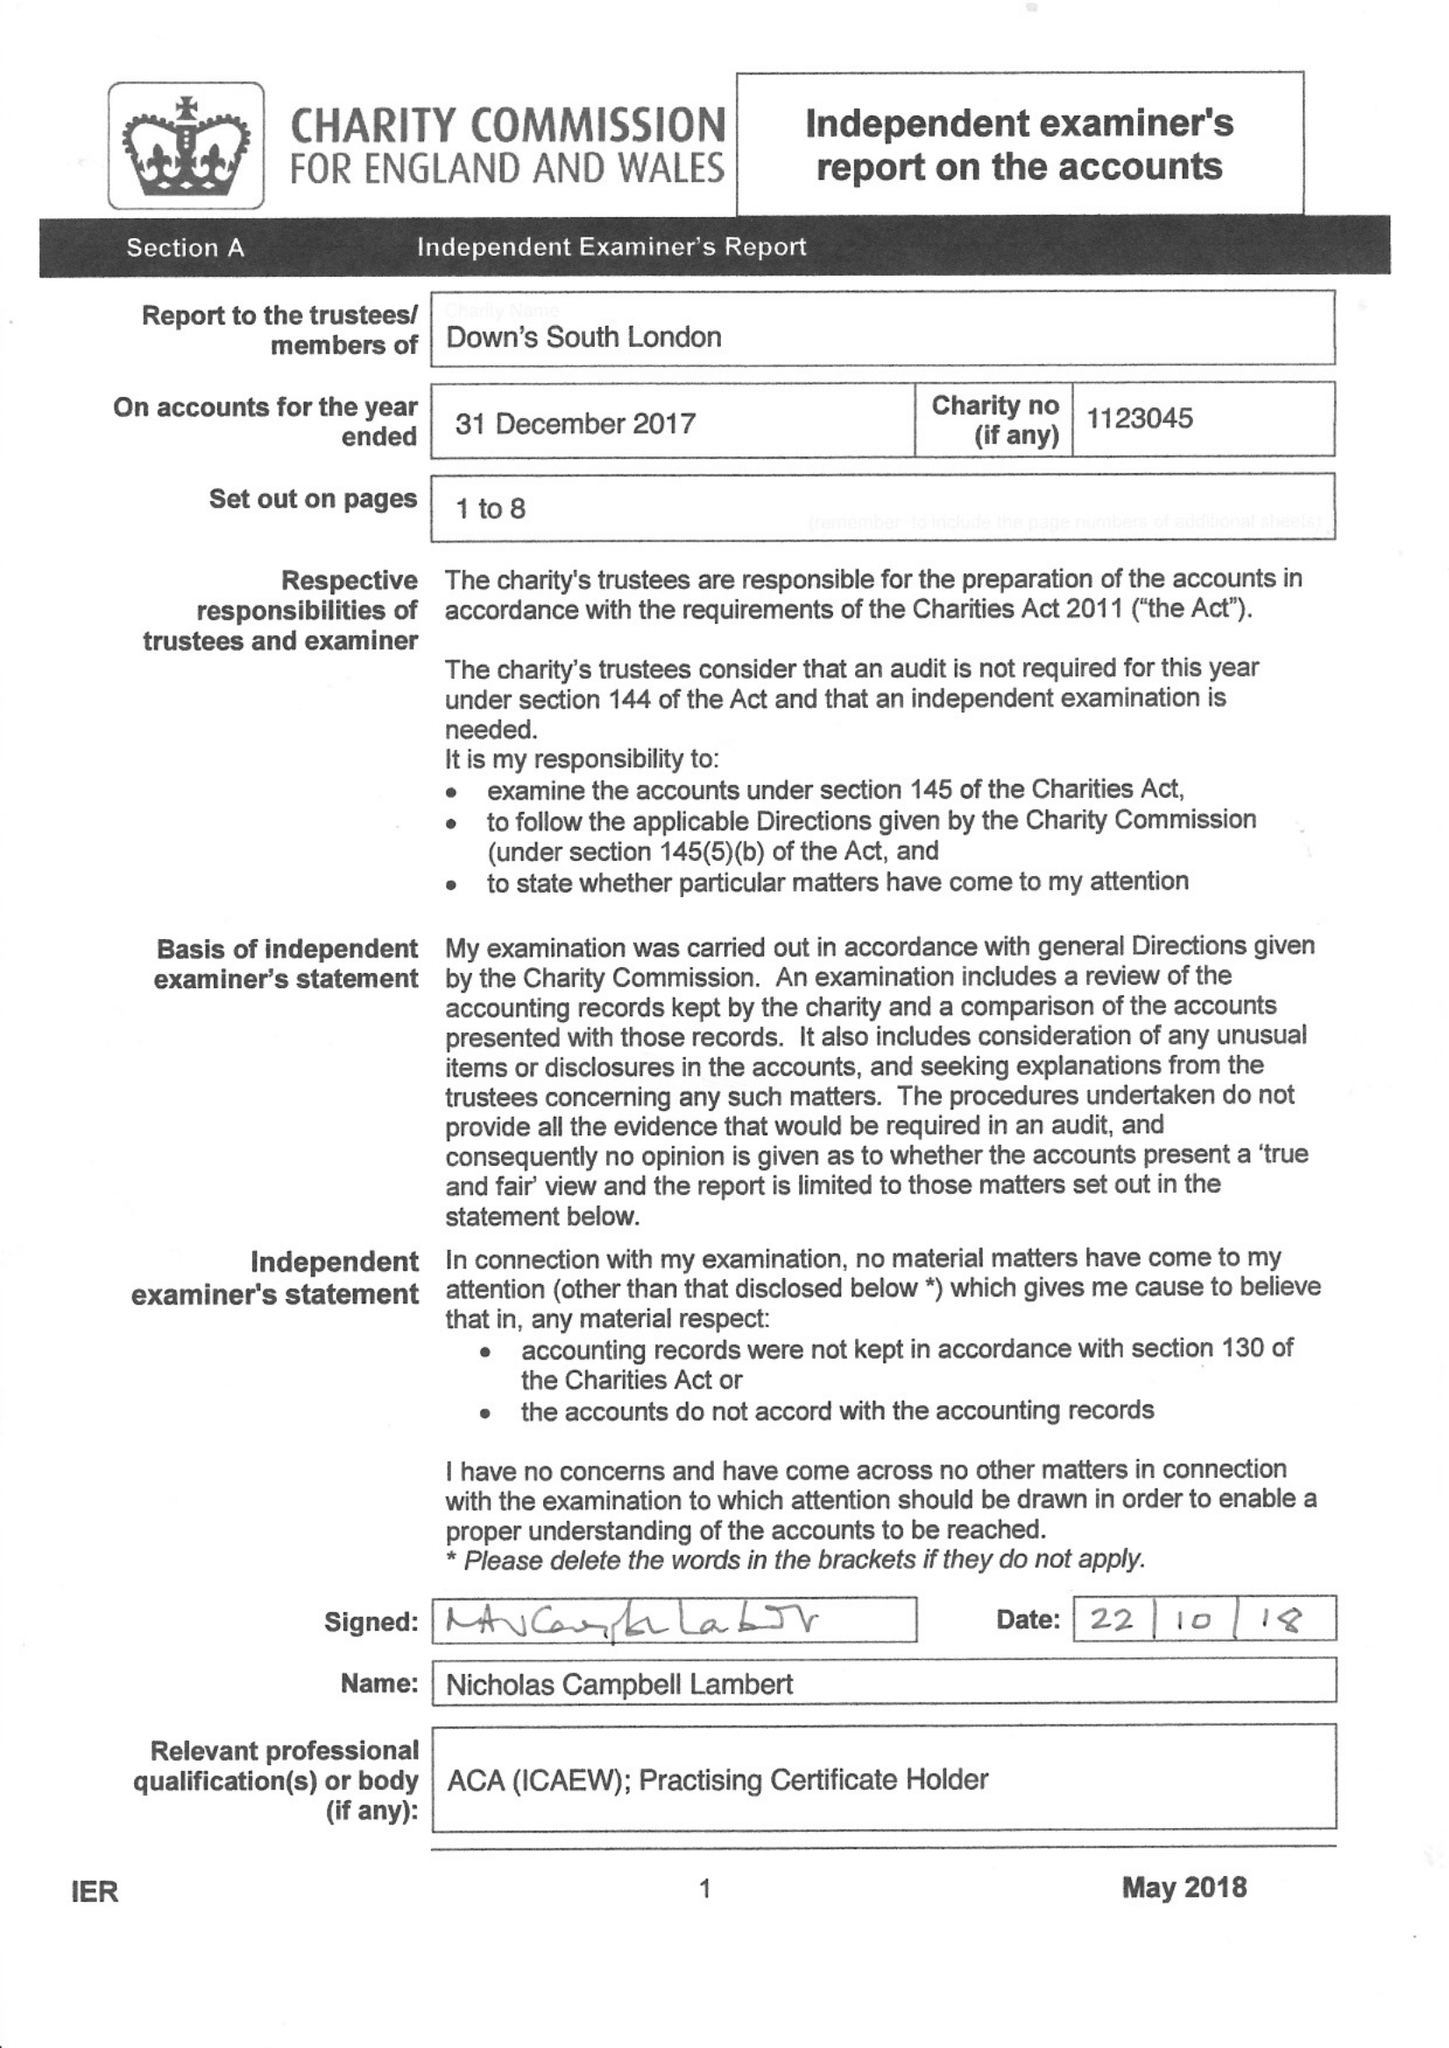What is the value for the spending_annually_in_british_pounds?
Answer the question using a single word or phrase. 100237.00 